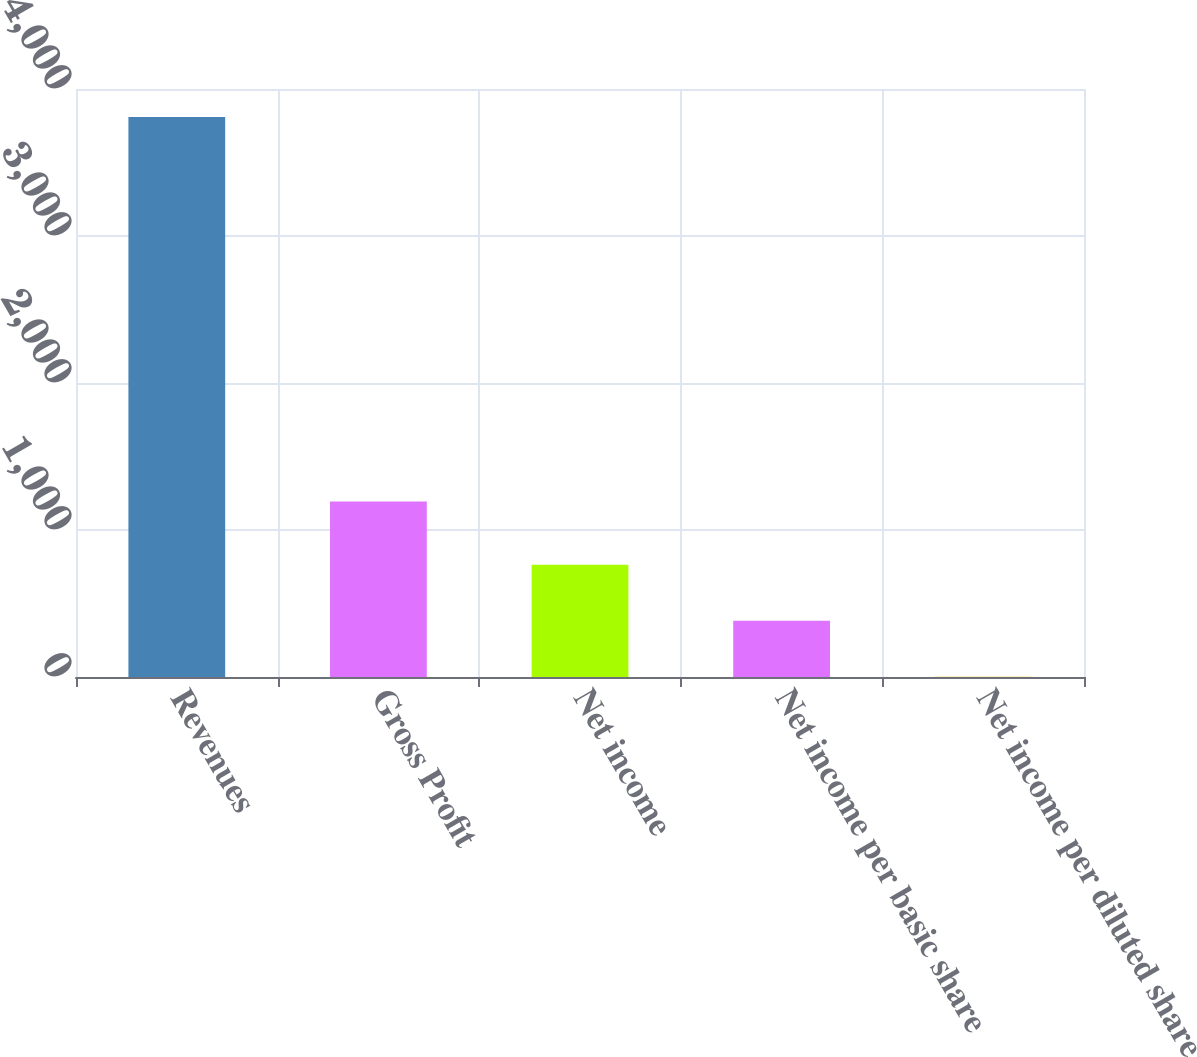Convert chart. <chart><loc_0><loc_0><loc_500><loc_500><bar_chart><fcel>Revenues<fcel>Gross Profit<fcel>Net income<fcel>Net income per basic share<fcel>Net income per diluted share<nl><fcel>3810.2<fcel>1193.4<fcel>763.16<fcel>382.28<fcel>1.4<nl></chart> 